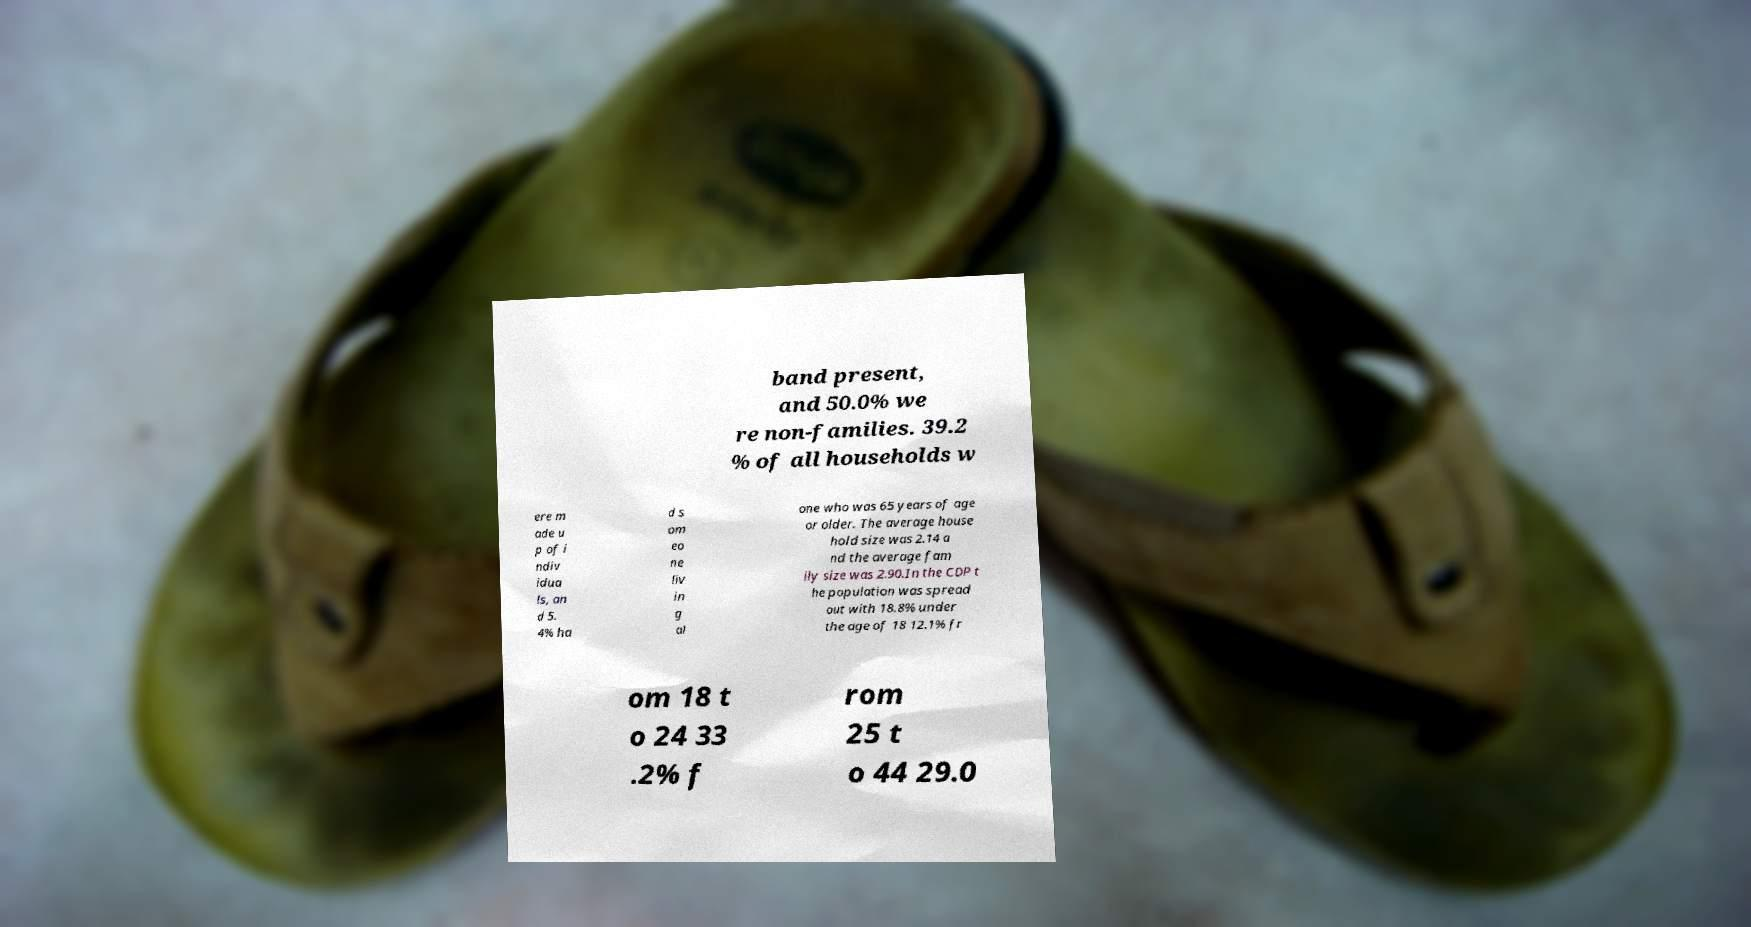Could you assist in decoding the text presented in this image and type it out clearly? band present, and 50.0% we re non-families. 39.2 % of all households w ere m ade u p of i ndiv idua ls, an d 5. 4% ha d s om eo ne liv in g al one who was 65 years of age or older. The average house hold size was 2.14 a nd the average fam ily size was 2.90.In the CDP t he population was spread out with 18.8% under the age of 18 12.1% fr om 18 t o 24 33 .2% f rom 25 t o 44 29.0 